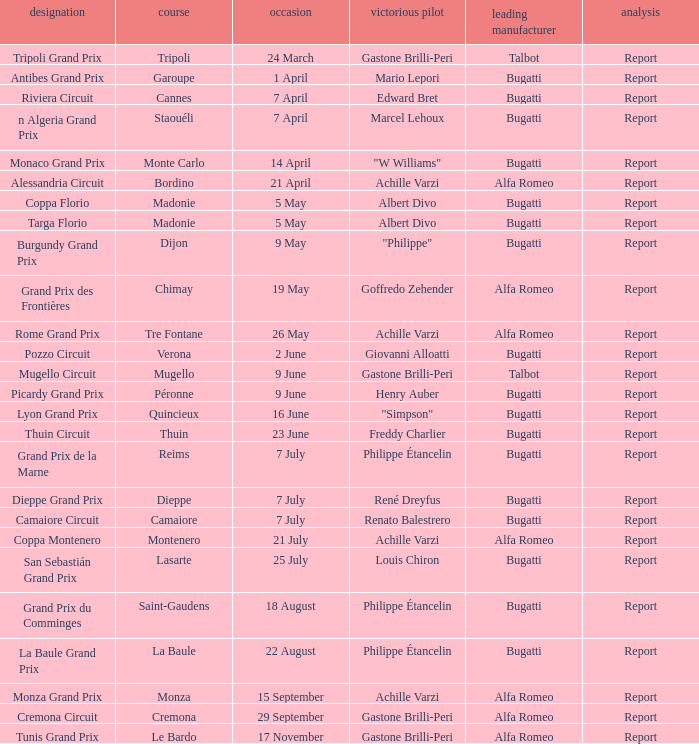What Circuit has a Winning constructor of bugatti, and a Winning driver of edward bret? Cannes. 